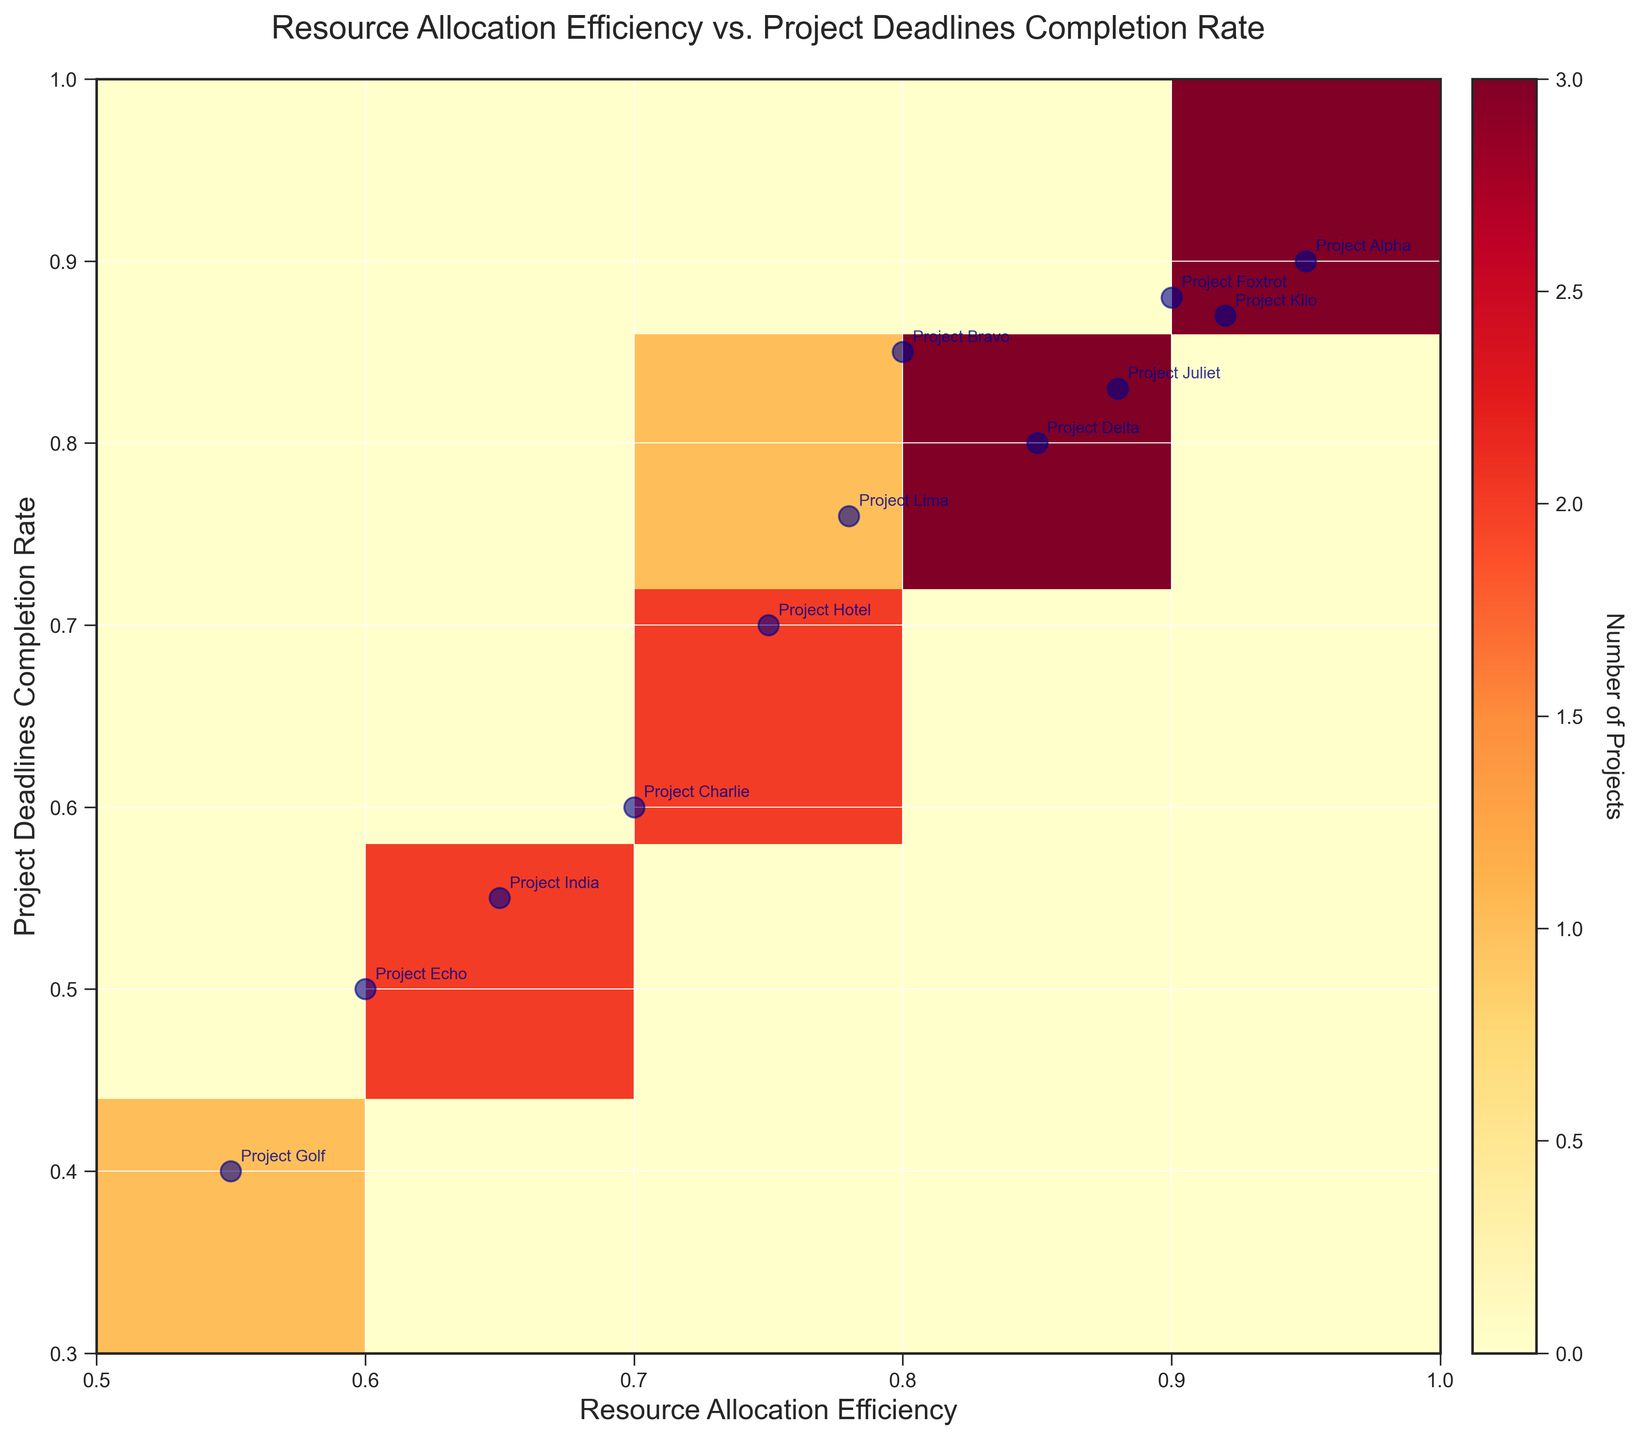What is the title of the heatmap? The title is usually written at the top of the figure. In this case, it reads "Resource Allocation Efficiency vs. Project Deadlines Completion Rate".
Answer: Resource Allocation Efficiency vs. Project Deadlines Completion Rate How many bins are used in both the x and y axes? From the labels on the axes, we see that the histogram's range is divided into sections. There are 5 bins on both the x and y axes.
Answer: 5 Which project has the highest Resource Allocation Efficiency? By looking at the scatter points with annotations, we identify the project at the far right end of the x-axis, annotated as Project Alpha.
Answer: Project Alpha Which project has the lowest Project Deadlines Completion Rate? By inspecting the scatter points with annotations, the project located at the bottom of the y-axis is Project Golf.
Answer: Project Golf Are there more projects with Resource Allocation Efficiency greater than 0.85 or less than 0.85? Counting the scatter points to the right of the 0.85 mark on the x-axis and comparing it with points to the left of this mark. There are 5 projects with efficiency > 0.85 and 7 projects with efficiency <= 0.85.
Answer: Less than 0.85 What is the range of Project Deadlines Completion Rate on the y-axis? The y-axis labels run from 0.3 to 1, indicated by the range on the heatmap.
Answer: 0.3 to 1 Which project lies closest to (0.75, 0.70)? By locating (0.75, 0.70) on the scatter plot and reading the annotation nearby, we can see that Project Hotel is the closest.
Answer: Project Hotel What's the average Project Deadlines Completion Rate for projects with Resource Allocation Efficiency above 0.85? Identifying the projects with Resource Allocation Efficiency above 0.85, their y-values are 0.90 (Alpha), 0.88 (Foxtrot), 0.87 (Kilo), 0.83 (Juliet). Sum these values (0.90 + 0.88 + 0.87 + 0.83) = 3.48 and divide by 4.
Answer: 0.87 How does the median Project Deadlines Completion Rate compare for projects with Resource Allocation Efficiency below 0.80 to those above 0.80? First, separate the projects into two groups: one with x-values < 0.80 and one with x-values > 0.80. Calculate medians of y-values for each group and compare them. Group1: [0.50, 0.40, 0.55, 0.70], median is (0.55+0.50)/2 = 0.525. Group2: [0.90, 0.85, 0.80, 0.88, 0.83, 0.87, 0.76], median is 0.85. So, median of Group2 is higher.
Answer: Median above 0.80 is higher How dense is the area of Resource Allocation Efficiency between 0.70 and 0.80 and Project Deadlines Completion Rate between 0.60 and 0.80? By inspecting the heatmap's color intensity and annotations, the yellow color (indicative of higher density) and several points fall within this range, indicating a higher density.
Answer: High density 